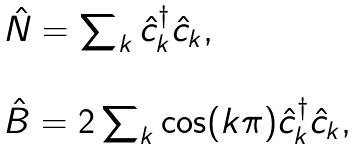<formula> <loc_0><loc_0><loc_500><loc_500>\begin{array} { l } \hat { N } = \sum _ { k } \hat { c } _ { k } ^ { \dagger } \hat { c } _ { k } , \\ \\ \hat { B } = 2 \sum _ { k } \cos ( k \pi ) \hat { c } _ { k } ^ { \dagger } \hat { c } _ { k } , \end{array}</formula> 